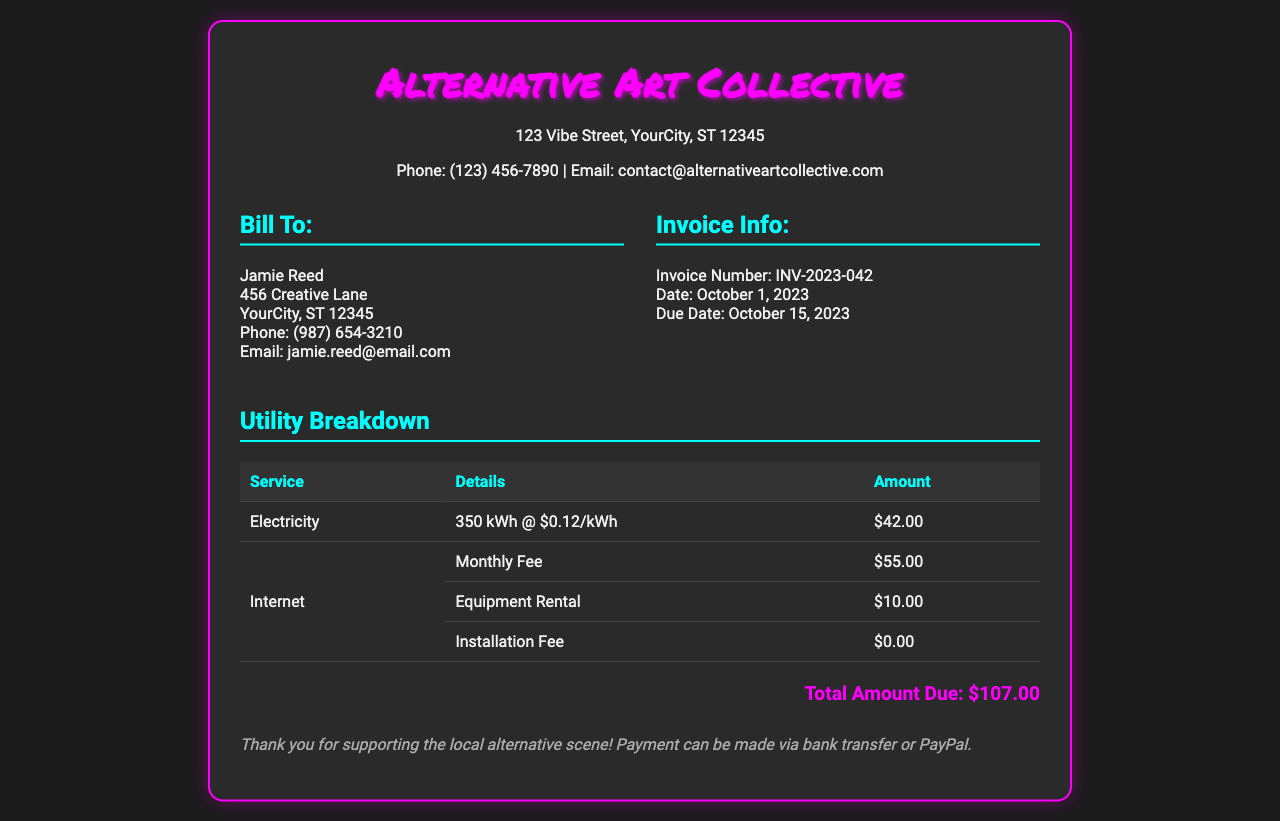What is the invoice number? The invoice number is listed in the document's invoice information section.
Answer: INV-2023-042 What is the total amount due? The total amount due is summarized at the bottom of the document.
Answer: $107.00 Who is the invoice billed to? The invoice details the person being billed, located in the "Bill To" section.
Answer: Jamie Reed What is the monthly fee for internet? The details of the internet charges include a specific monthly fee.
Answer: $55.00 How much was charged for electricity? The electricity charges are detailed in the utility breakdown section.
Answer: $42.00 What is the due date for payment? The due date is indicated in the invoice information section.
Answer: October 15, 2023 How many kilowatt-hours were consumed? The document specifies the amount of electricity consumed.
Answer: 350 kWh What is the address of the studio? The studio address is displayed in the header of the invoice.
Answer: 123 Vibe Street, YourCity, ST 12345 What was the installation fee for internet? The installation fee is part of the internet charges detailed in the breakdown.
Answer: $0.00 